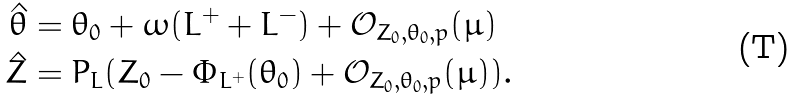Convert formula to latex. <formula><loc_0><loc_0><loc_500><loc_500>\hat { \theta } & = \theta _ { 0 } + \omega ( L ^ { + } + L ^ { - } ) + { \mathcal { O } } _ { Z _ { 0 } , \theta _ { 0 } , p } ( \mu ) \\ \hat { Z } & = P _ { L } ( Z _ { 0 } - \Phi _ { L ^ { + } } ( \theta _ { 0 } ) + { \mathcal { O } } _ { Z _ { 0 } , \theta _ { 0 } , p } ( \mu ) ) .</formula> 